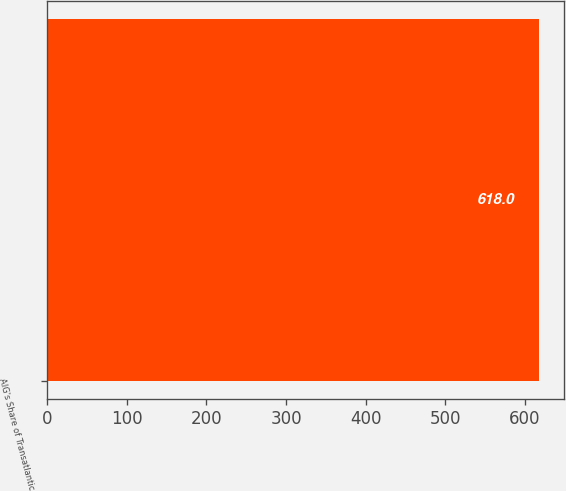Convert chart. <chart><loc_0><loc_0><loc_500><loc_500><bar_chart><fcel>AIG's Share of Transatlantic<nl><fcel>618<nl></chart> 